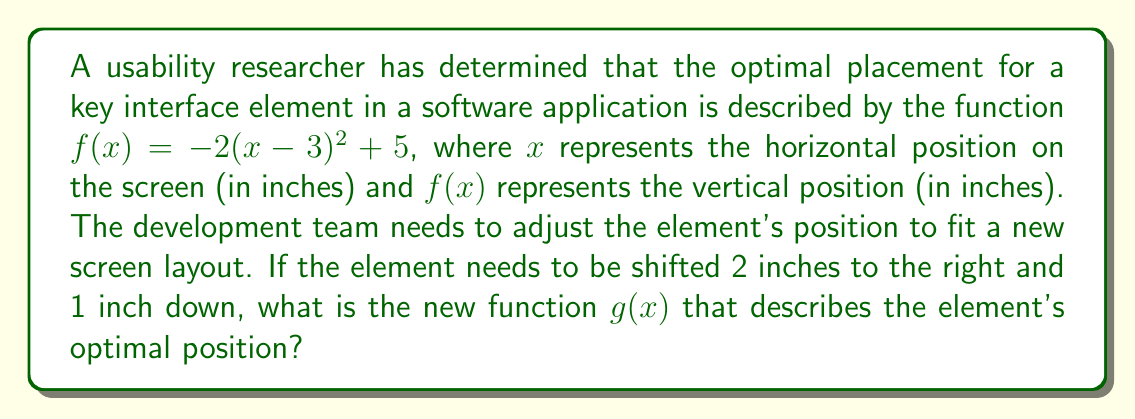Can you solve this math problem? To solve this problem, we need to apply horizontal and vertical transformations to the original function $f(x)$. Let's break it down step-by-step:

1. Original function: $f(x) = -2(x-3)^2 + 5$

2. Horizontal shift:
   - To shift 2 inches to the right, we replace $x$ with $(x-2)$
   - This gives us: $-2((x-2)-3)^2 + 5$

3. Simplify the expression inside the parentheses:
   $-2((x-2)-3)^2 + 5 = -2(x-5)^2 + 5$

4. Vertical shift:
   - To shift 1 inch down, we subtract 1 from the entire function
   - This gives us: $-2(x-5)^2 + 5 - 1$

5. Simplify the constant term:
   $-2(x-5)^2 + 4$

Therefore, the new function $g(x)$ that describes the element's optimal position after the shifts is:

$g(x) = -2(x-5)^2 + 4$
Answer: $g(x) = -2(x-5)^2 + 4$ 